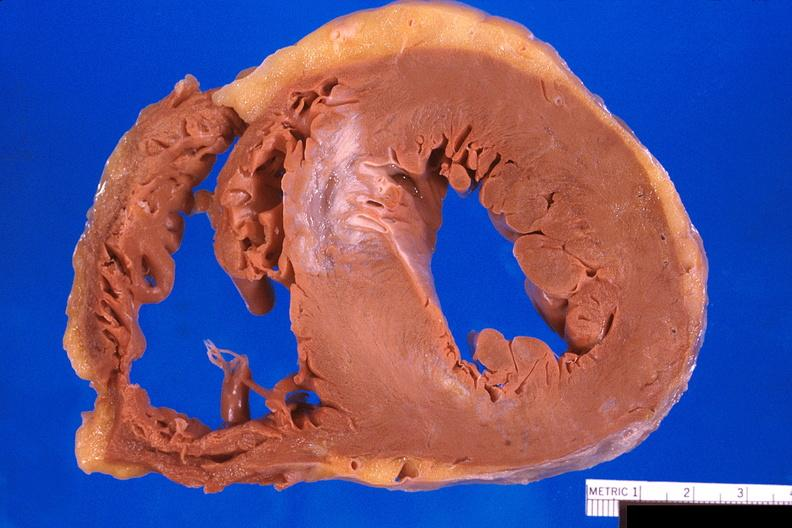s cardiovascular present?
Answer the question using a single word or phrase. Yes 